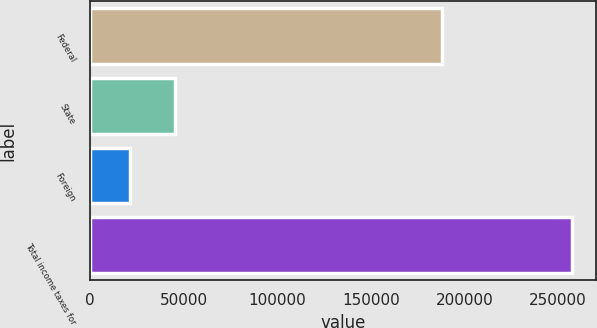Convert chart. <chart><loc_0><loc_0><loc_500><loc_500><bar_chart><fcel>Federal<fcel>State<fcel>Foreign<fcel>Total income taxes for<nl><fcel>188086<fcel>45072.4<fcel>21456<fcel>257620<nl></chart> 